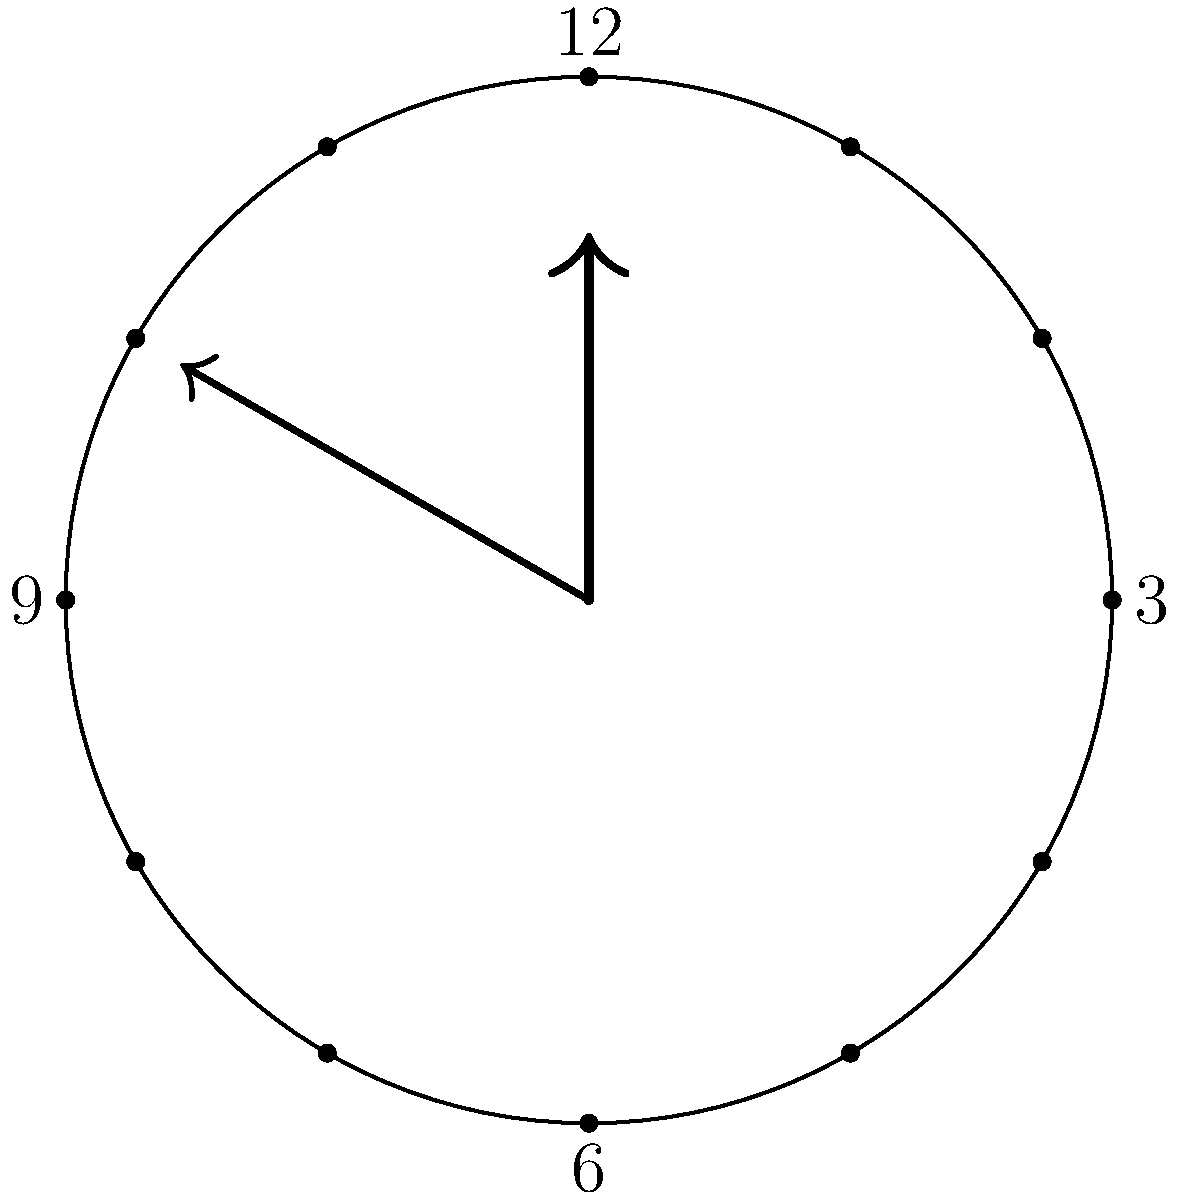On your favorite TV show, there's a close-up of an analog clock. The hour hand is pointing exactly at 3, and the minute hand is pointing at 25 minutes past the hour. What is the angle between the hour and minute hands? Let's approach this step-by-step:

1) First, we need to calculate the angle of each hand from the 12 o'clock position:

   - The hour hand: 3 hours = $\frac{3}{12} \times 360° = 90°$
   - The minute hand: 25 minutes = $\frac{25}{60} \times 360° = 150°$

2) Now, we can find the angle between the hands by subtracting:

   $150° - 90° = 60°$

3) However, we need to consider that the hour hand also moves slightly as the minutes pass. In one hour, it moves 30°. So in 25 minutes, it moves:

   $\frac{25}{60} \times 30° = 12.5°$

4) So the actual position of the hour hand is:

   $90° + 12.5° = 102.5°$

5) Now we can calculate the actual angle between the hands:

   $150° - 102.5° = 47.5°$

Therefore, the angle between the hour and minute hands is 47.5°.
Answer: $47.5°$ 